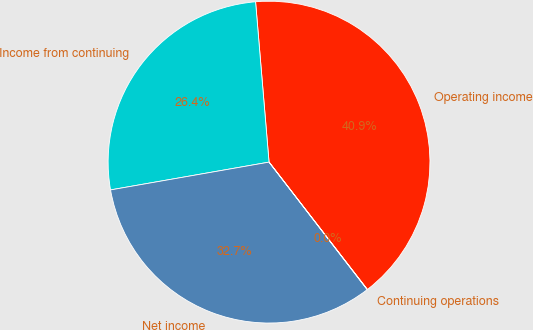Convert chart to OTSL. <chart><loc_0><loc_0><loc_500><loc_500><pie_chart><fcel>Operating income<fcel>Income from continuing<fcel>Net income<fcel>Continuing operations<nl><fcel>40.87%<fcel>26.43%<fcel>32.68%<fcel>0.02%<nl></chart> 